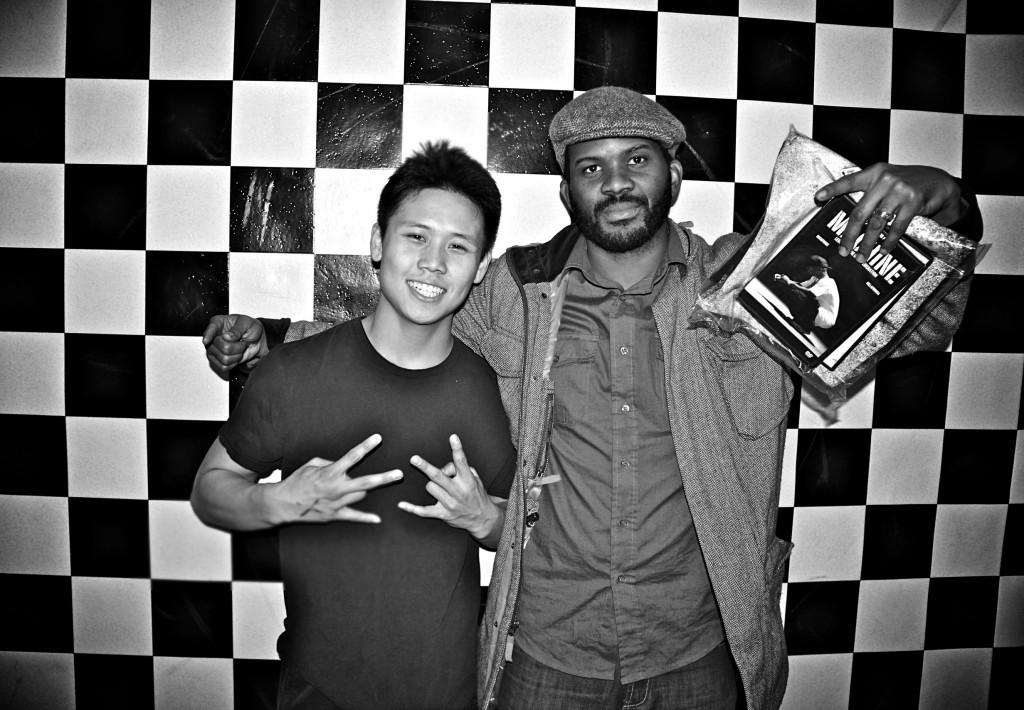How many people are in the image? There are two persons standing in the middle of the image. What are the expressions on their faces? Both persons are smiling. What is one person holding in the image? One person is holding a cover. What can be seen behind the two persons? There is a wall visible behind the two persons. What type of stage can be seen in the background of the image? There is no stage present in the image; it features two persons standing in front of a wall. Who is the mom in the image? There is no reference to a mom or any familial relationship in the image. 